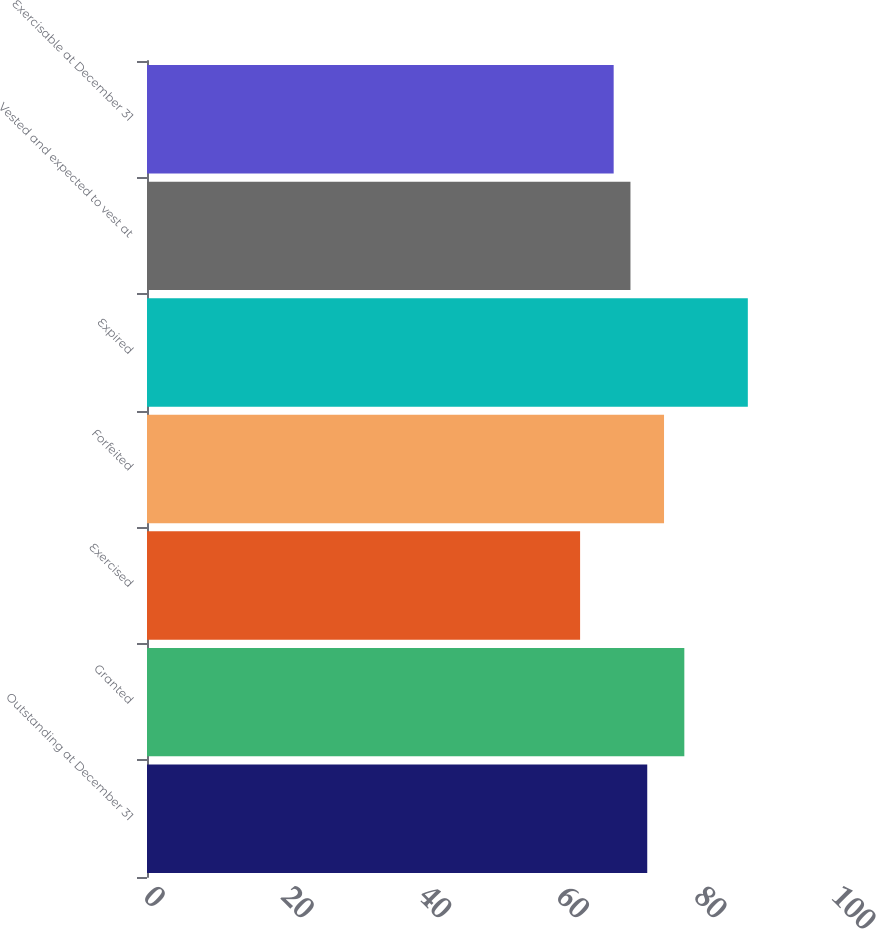Convert chart to OTSL. <chart><loc_0><loc_0><loc_500><loc_500><bar_chart><fcel>Outstanding at December 31<fcel>Granted<fcel>Exercised<fcel>Forfeited<fcel>Expired<fcel>Vested and expected to vest at<fcel>Exercisable at December 31<nl><fcel>72.71<fcel>78.1<fcel>62.95<fcel>75.15<fcel>87.33<fcel>70.27<fcel>67.83<nl></chart> 